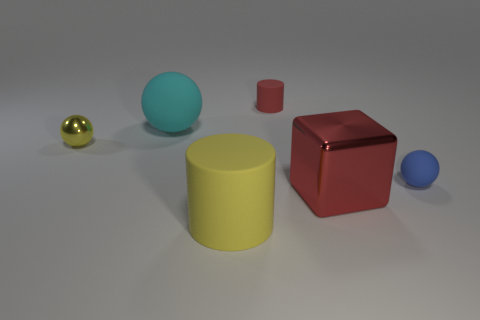Add 3 blue spheres. How many objects exist? 9 Subtract all cubes. How many objects are left? 5 Add 3 matte things. How many matte things are left? 7 Add 6 large shiny cylinders. How many large shiny cylinders exist? 6 Subtract 0 blue cylinders. How many objects are left? 6 Subtract all small yellow balls. Subtract all matte cylinders. How many objects are left? 3 